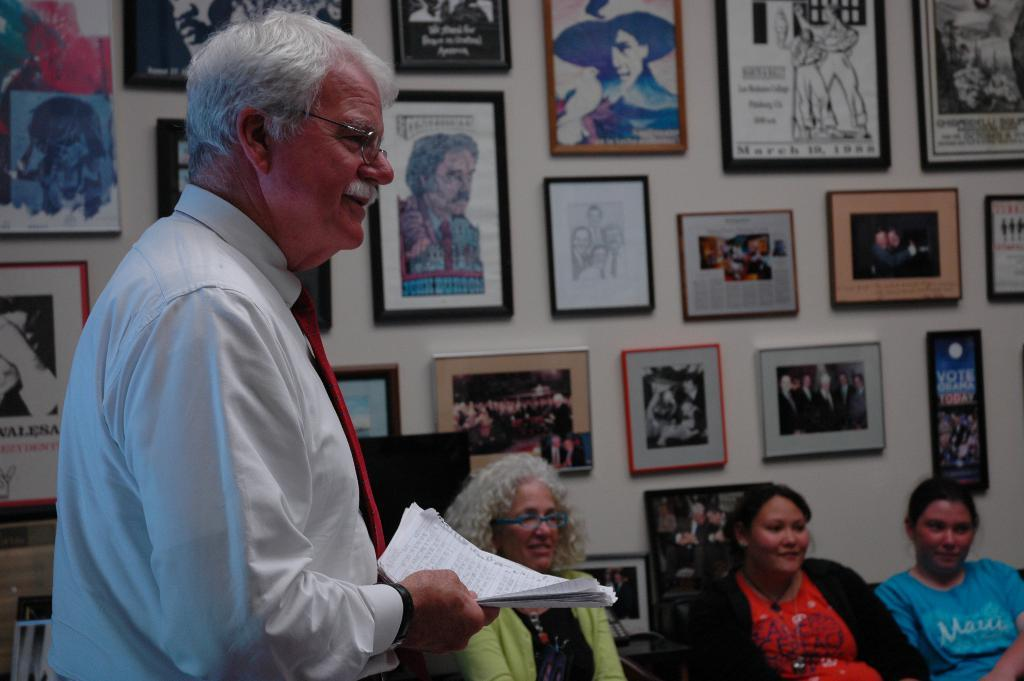What is the appearance of the person on the left side of the image? The person is wearing specs and a tie. What is the person holding in the image? The person is holding some papers. How many ladies are sitting in the image? There are three ladies sitting in the image. What can be seen on the wall in the background of the image? There are photo frames on the wall in the background of the image. What type of bead is being used to decorate the dress of the lady in the image? There is no mention of a dress or beads in the image; the focus is on the person wearing specs and a tie and the three ladies sitting. 